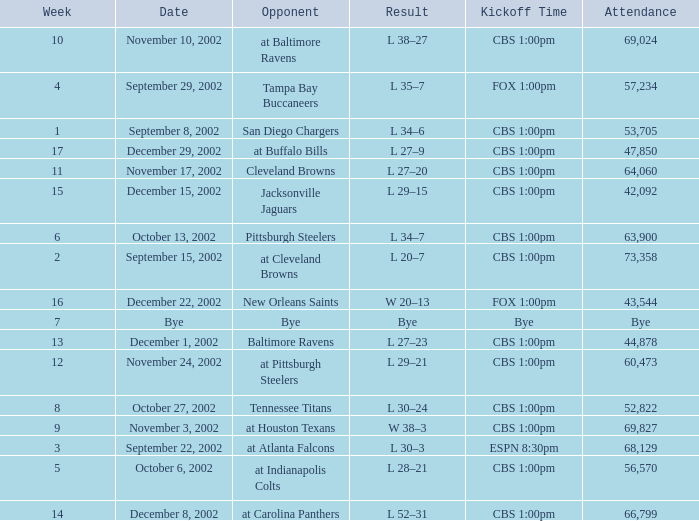What is the kickoff time for the game in week of 17? CBS 1:00pm. 